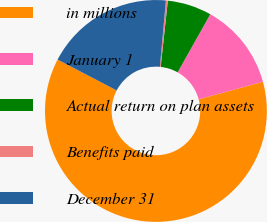Convert chart to OTSL. <chart><loc_0><loc_0><loc_500><loc_500><pie_chart><fcel>in millions<fcel>January 1<fcel>Actual return on plan assets<fcel>Benefits paid<fcel>December 31<nl><fcel>61.9%<fcel>12.61%<fcel>6.44%<fcel>0.28%<fcel>18.77%<nl></chart> 